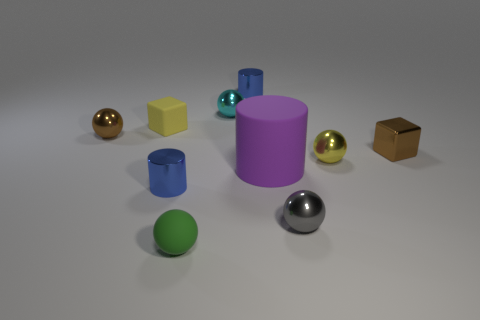Is there any other thing that has the same material as the small brown cube?
Your answer should be very brief. Yes. What is the size of the cyan object?
Make the answer very short. Small. There is a object that is the same color as the shiny cube; what shape is it?
Give a very brief answer. Sphere. How many tiny yellow objects are on the left side of the small blue shiny thing that is in front of the small cyan object?
Your answer should be compact. 1. Are there fewer large objects on the right side of the big purple cylinder than brown metallic objects behind the brown metallic cube?
Make the answer very short. Yes. There is a small shiny thing to the left of the tiny blue metal cylinder in front of the big purple thing; what shape is it?
Provide a succinct answer. Sphere. What number of other objects are the same material as the tiny brown cube?
Make the answer very short. 6. Is there anything else that has the same size as the purple matte cylinder?
Offer a terse response. No. Is the number of small gray shiny balls greater than the number of small things?
Keep it short and to the point. No. There is a yellow object behind the tiny yellow metal thing in front of the rubber thing left of the tiny green thing; how big is it?
Make the answer very short. Small. 